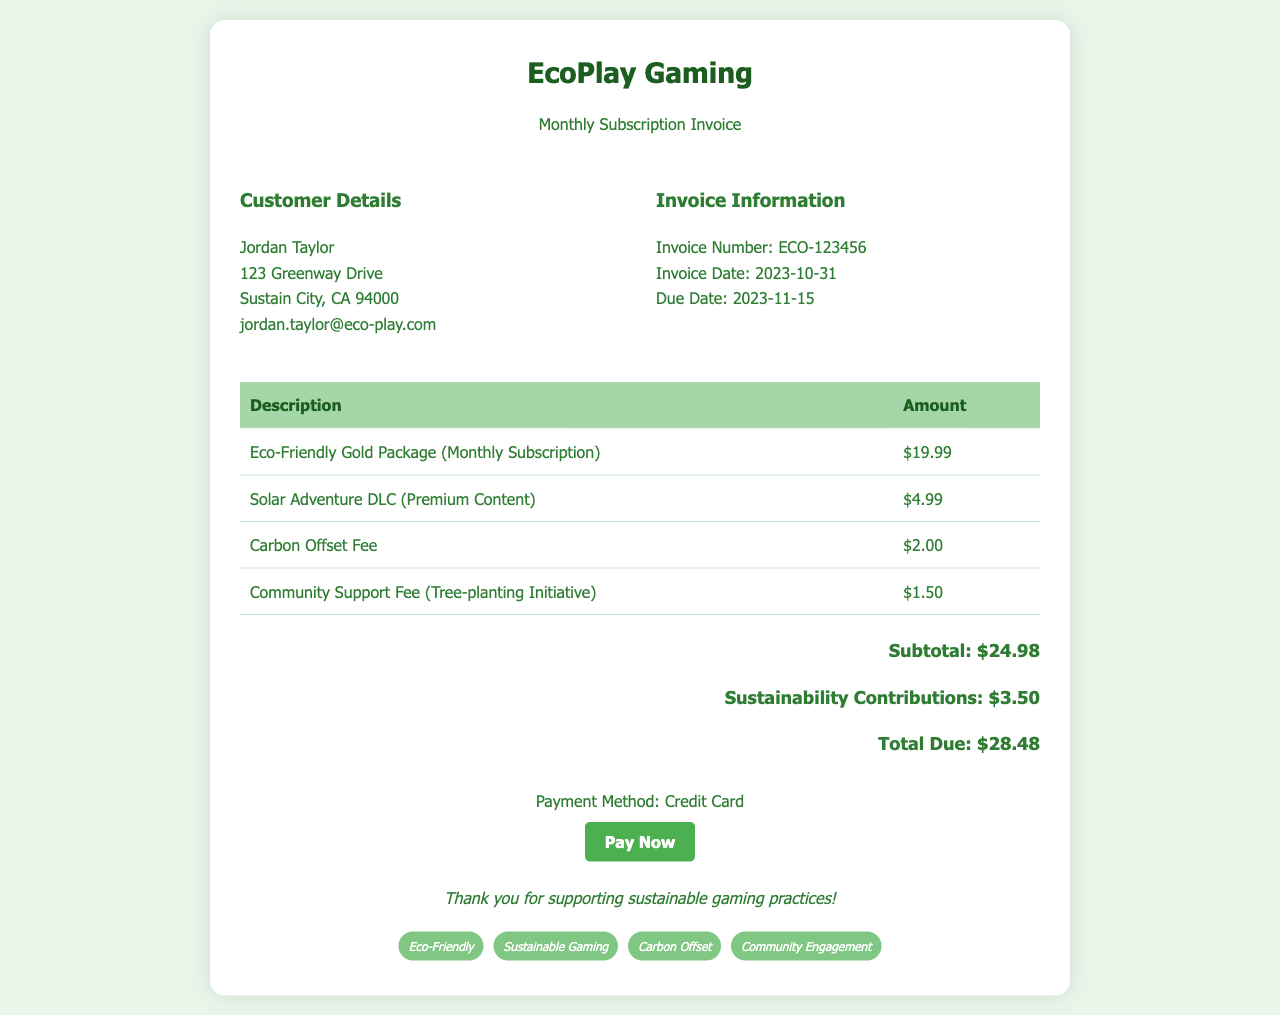What is the name of the gaming platform? The name of the gaming platform is mentioned in the header of the document.
Answer: EcoPlay Gaming What is the invoice number? The invoice number is listed under the invoice information section.
Answer: ECO-123456 What is the total amount due? The total amount due is calculated and presented in the total section of the invoice.
Answer: $28.48 When is the invoice due date? The due date is provided in the invoice information section.
Answer: 2023-11-15 What is the amount of the Carbon Offset Fee? The Carbon Offset Fee is one of the listed items on the invoice.
Answer: $2.00 What are the sustainability contributions listed? The sustainability contributions are found in the total section of the invoice and are part of the total calculations.
Answer: $3.50 How much is the Eco-Friendly Gold Package? The price of the Eco-Friendly Gold Package is given in the invoice table.
Answer: $19.99 What is the customer's email address? The customer's contact information is found in the customer details section.
Answer: jordan.taylor@eco-play.com What additional charge is related to community support? The community support fee is described in the invoice table.
Answer: $1.50 